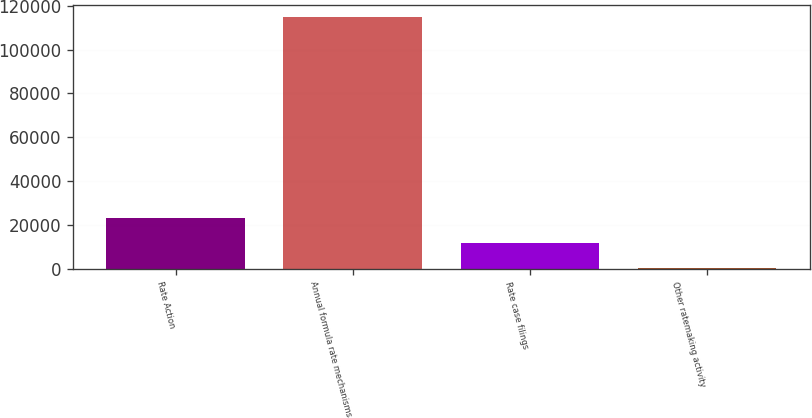Convert chart. <chart><loc_0><loc_0><loc_500><loc_500><bar_chart><fcel>Rate Action<fcel>Annual formula rate mechanisms<fcel>Rate case filings<fcel>Other ratemaking activity<nl><fcel>23133.2<fcel>114810<fcel>11673.6<fcel>214<nl></chart> 